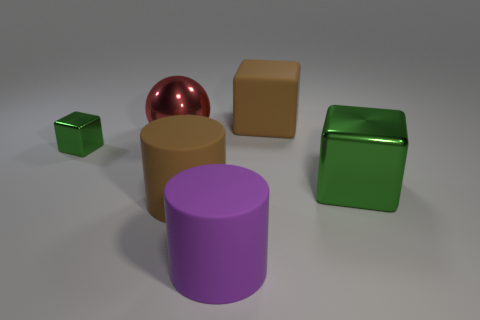What is the size of the purple cylinder that is made of the same material as the brown block?
Give a very brief answer. Large. What number of large balls have the same color as the tiny object?
Provide a succinct answer. 0. Is the number of green blocks to the left of the small thing less than the number of large green objects behind the big red shiny object?
Provide a short and direct response. No. There is a green thing in front of the tiny green object; is its shape the same as the red shiny object?
Give a very brief answer. No. Do the large brown thing that is on the right side of the large brown cylinder and the small green block have the same material?
Make the answer very short. No. What material is the green object that is on the left side of the green metallic thing that is to the right of the cube that is to the left of the big purple rubber cylinder?
Your answer should be very brief. Metal. What number of other objects are there of the same shape as the tiny green object?
Make the answer very short. 2. What color is the large metallic object that is behind the tiny green block?
Your answer should be compact. Red. There is a object that is right of the brown thing behind the small metallic object; what number of big matte blocks are left of it?
Provide a short and direct response. 1. How many brown matte cylinders are in front of the big rubber cylinder that is in front of the brown rubber cylinder?
Your answer should be very brief. 0. 